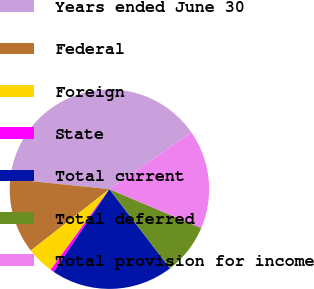Convert chart. <chart><loc_0><loc_0><loc_500><loc_500><pie_chart><fcel>Years ended June 30<fcel>Federal<fcel>Foreign<fcel>State<fcel>Total current<fcel>Total deferred<fcel>Total provision for income<nl><fcel>38.72%<fcel>12.19%<fcel>4.42%<fcel>0.61%<fcel>19.82%<fcel>8.23%<fcel>16.01%<nl></chart> 